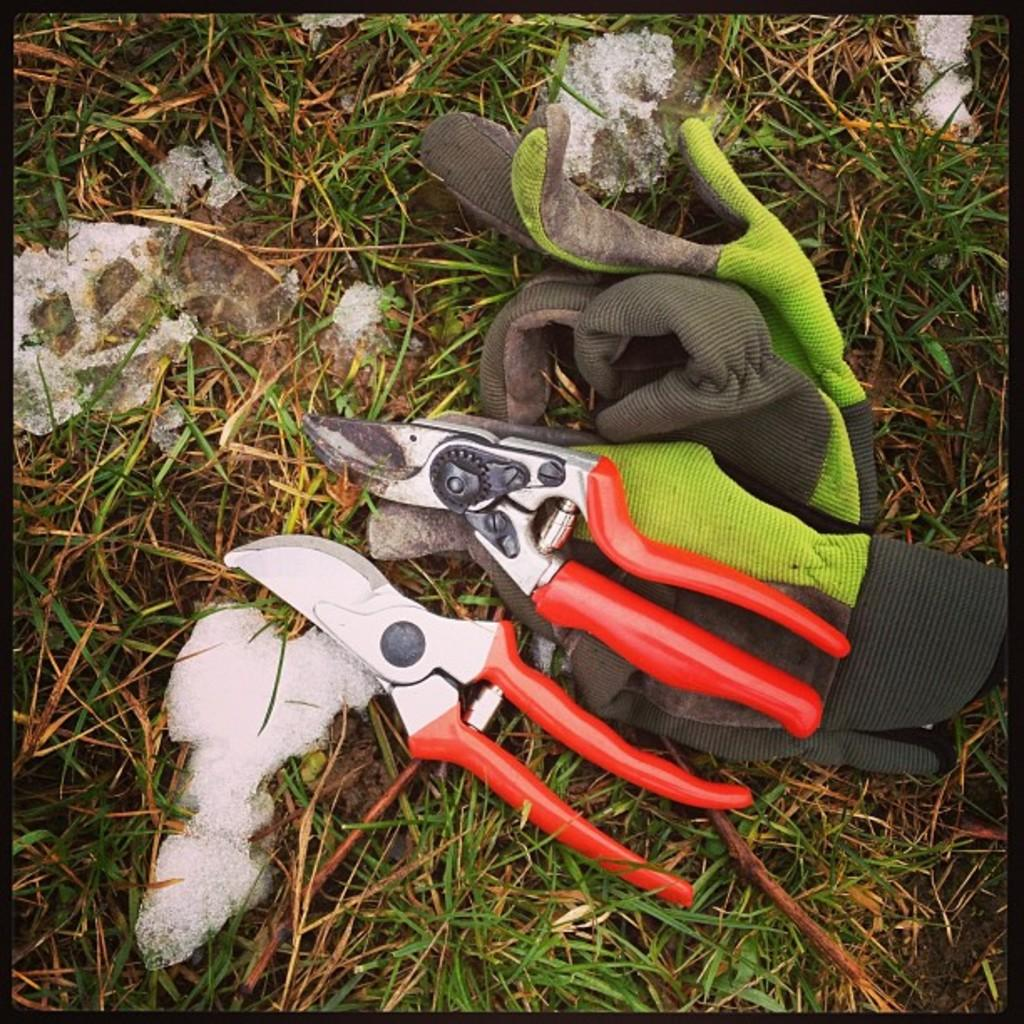What type of hand protection is shown in the image? There are gloves in the image. What tool is also present in the image? There are cutting-pliers in the image. What type of natural environment can be seen in the image? There is grass visible in the image. What type of flower is being rolled up in the image? There is no flower present in the image, nor is there any rolling or connection activity taking place. 